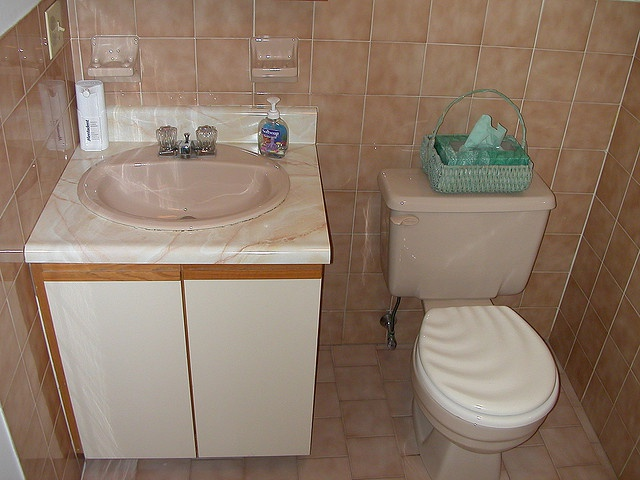Describe the objects in this image and their specific colors. I can see toilet in darkgray and gray tones and sink in darkgray, gray, and tan tones in this image. 